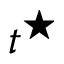<formula> <loc_0><loc_0><loc_500><loc_500>t ^ { ^ { * } }</formula> 